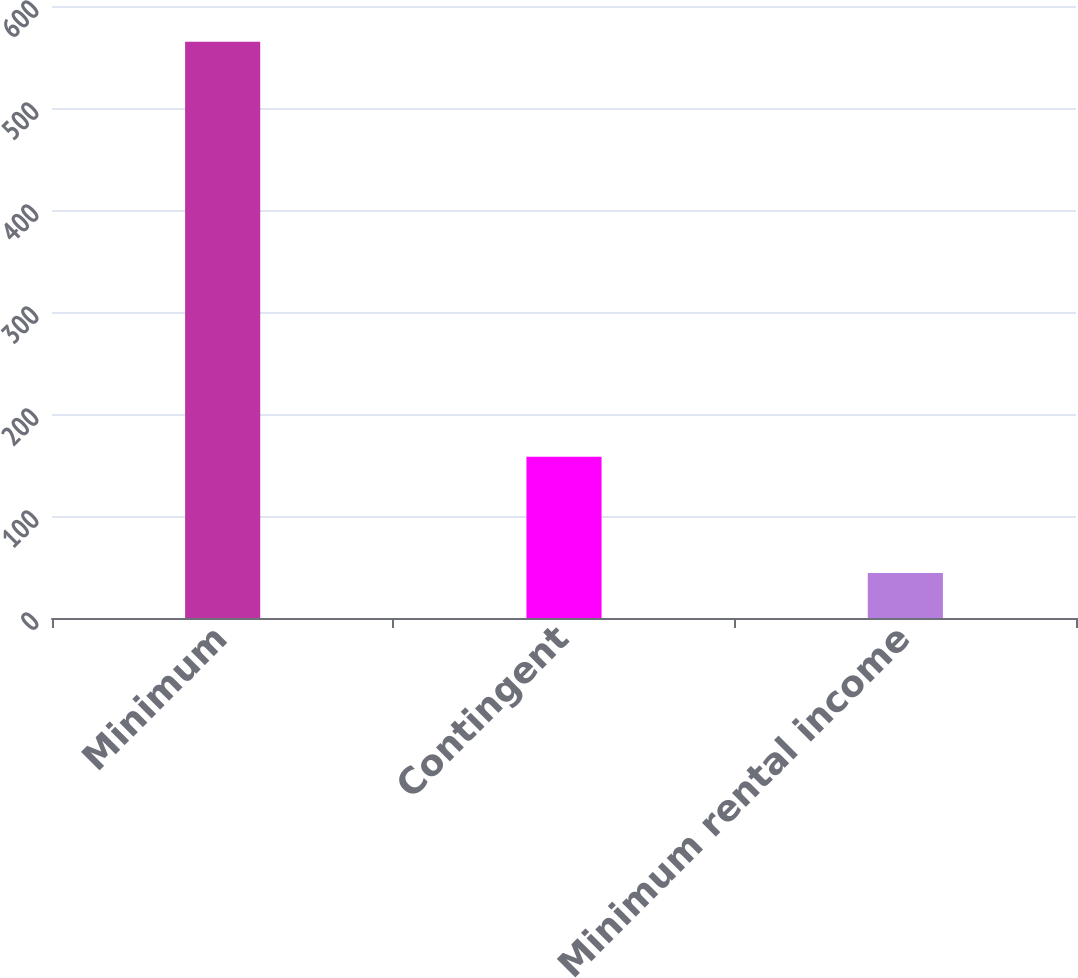Convert chart. <chart><loc_0><loc_0><loc_500><loc_500><bar_chart><fcel>Minimum<fcel>Contingent<fcel>Minimum rental income<nl><fcel>565<fcel>158<fcel>44<nl></chart> 